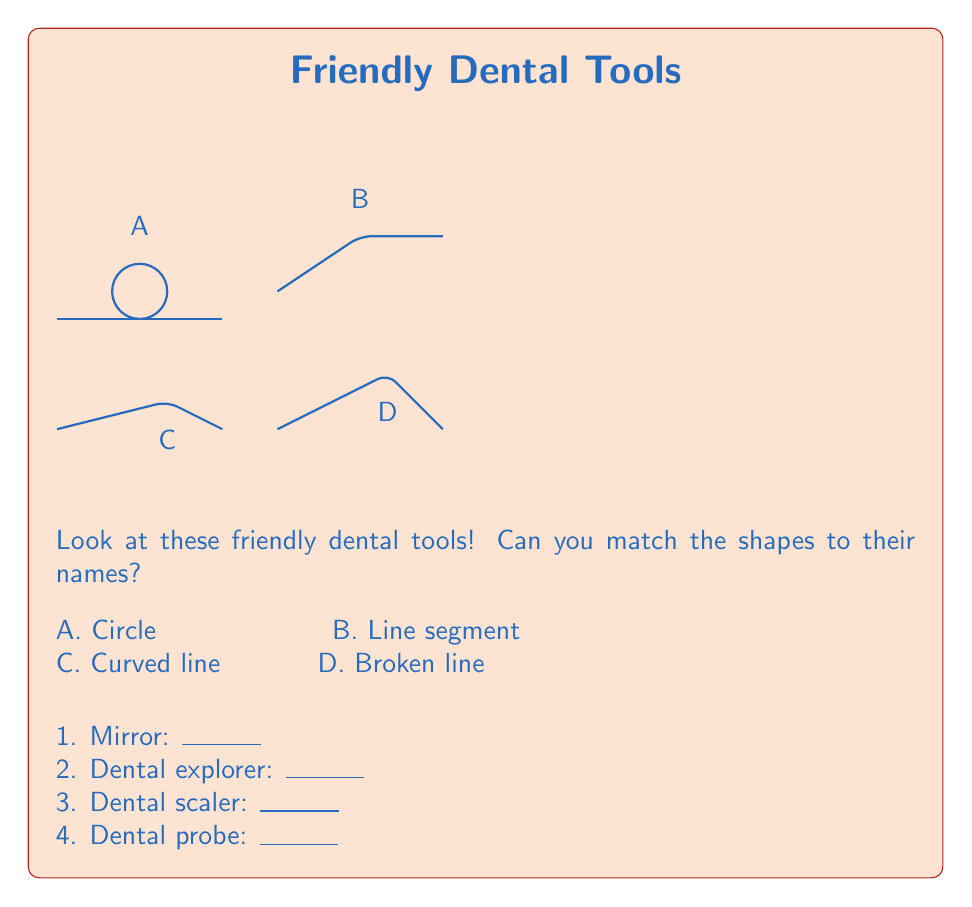Teach me how to tackle this problem. Let's look at each dental tool and its shape:

1. Mirror (A): The mirror has a circular reflecting surface attached to a handle. The circular part is represented by a perfect circle shape.

2. Dental explorer (B): This tool has a long, straight handle with a slightly curved tip. The main body of the explorer is represented by a straight line segment.

3. Dental scaler (C): The scaler has a curved shape that helps in removing plaque and tartar. It's represented by a single curved line.

4. Dental probe (D): The probe has a long handle with a bent tip, creating an angle. This is represented by two connected line segments forming a broken line.

By matching the shapes to their descriptions, we can determine which letter corresponds to each dental tool.
Answer: 1. A, 2. B, 3. C, 4. D 